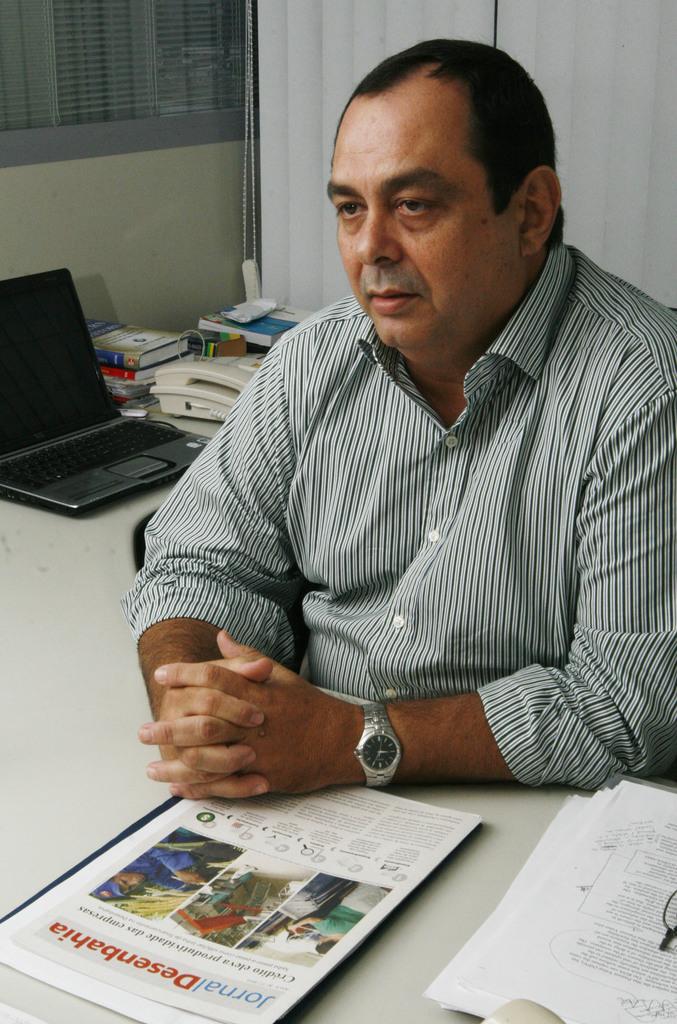What is written in red on the paper in front of the man?
Your response must be concise. Desenbahia. 